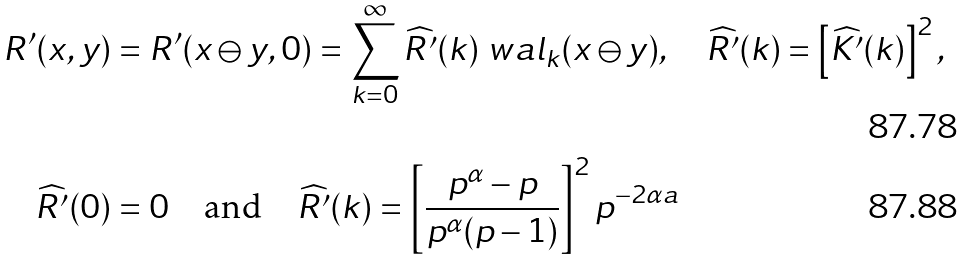Convert formula to latex. <formula><loc_0><loc_0><loc_500><loc_500>R ^ { \prime } ( x , y ) & = R ^ { \prime } ( x \ominus y , 0 ) = \sum _ { k = 0 } ^ { \infty } \widehat { R ^ { \prime } } ( k ) \ w a l _ { k } ( x \ominus y ) , \quad \widehat { R ^ { \prime } } ( k ) = \left [ \widehat { K ^ { \prime } } ( k ) \right ] ^ { 2 } , \\ \widehat { R ^ { \prime } } ( 0 ) & = 0 \quad \text {and} \quad \widehat { R ^ { \prime } } ( k ) = \left [ \frac { p ^ { \alpha } - p } { p ^ { \alpha } ( p - 1 ) } \right ] ^ { 2 } p ^ { - 2 \alpha a }</formula> 